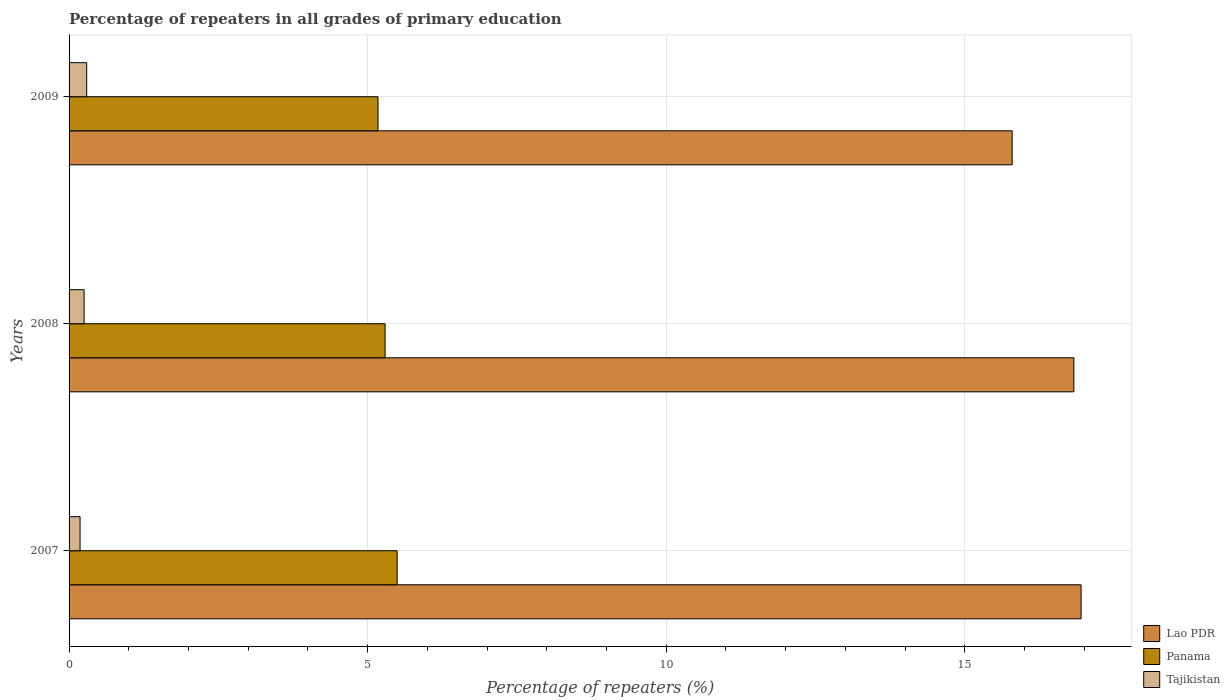How many different coloured bars are there?
Ensure brevity in your answer.  3. How many groups of bars are there?
Your response must be concise. 3. Are the number of bars per tick equal to the number of legend labels?
Provide a short and direct response. Yes. Are the number of bars on each tick of the Y-axis equal?
Provide a succinct answer. Yes. What is the percentage of repeaters in Tajikistan in 2008?
Make the answer very short. 0.25. Across all years, what is the maximum percentage of repeaters in Lao PDR?
Keep it short and to the point. 16.95. Across all years, what is the minimum percentage of repeaters in Lao PDR?
Offer a terse response. 15.79. In which year was the percentage of repeaters in Lao PDR maximum?
Your answer should be very brief. 2007. In which year was the percentage of repeaters in Tajikistan minimum?
Your answer should be very brief. 2007. What is the total percentage of repeaters in Panama in the graph?
Ensure brevity in your answer.  15.96. What is the difference between the percentage of repeaters in Panama in 2007 and that in 2009?
Ensure brevity in your answer.  0.32. What is the difference between the percentage of repeaters in Panama in 2009 and the percentage of repeaters in Lao PDR in 2008?
Your response must be concise. -11.65. What is the average percentage of repeaters in Lao PDR per year?
Make the answer very short. 16.52. In the year 2009, what is the difference between the percentage of repeaters in Lao PDR and percentage of repeaters in Tajikistan?
Keep it short and to the point. 15.5. In how many years, is the percentage of repeaters in Tajikistan greater than 9 %?
Offer a terse response. 0. What is the ratio of the percentage of repeaters in Tajikistan in 2008 to that in 2009?
Provide a succinct answer. 0.85. What is the difference between the highest and the second highest percentage of repeaters in Lao PDR?
Provide a succinct answer. 0.12. What is the difference between the highest and the lowest percentage of repeaters in Panama?
Your answer should be compact. 0.32. Is the sum of the percentage of repeaters in Lao PDR in 2007 and 2008 greater than the maximum percentage of repeaters in Panama across all years?
Offer a terse response. Yes. What does the 2nd bar from the top in 2007 represents?
Your answer should be very brief. Panama. What does the 1st bar from the bottom in 2007 represents?
Offer a very short reply. Lao PDR. Is it the case that in every year, the sum of the percentage of repeaters in Panama and percentage of repeaters in Lao PDR is greater than the percentage of repeaters in Tajikistan?
Offer a terse response. Yes. How many bars are there?
Offer a terse response. 9. Does the graph contain any zero values?
Keep it short and to the point. No. How are the legend labels stacked?
Your response must be concise. Vertical. What is the title of the graph?
Ensure brevity in your answer.  Percentage of repeaters in all grades of primary education. What is the label or title of the X-axis?
Provide a short and direct response. Percentage of repeaters (%). What is the Percentage of repeaters (%) of Lao PDR in 2007?
Provide a succinct answer. 16.95. What is the Percentage of repeaters (%) of Panama in 2007?
Offer a very short reply. 5.49. What is the Percentage of repeaters (%) in Tajikistan in 2007?
Provide a short and direct response. 0.18. What is the Percentage of repeaters (%) of Lao PDR in 2008?
Keep it short and to the point. 16.82. What is the Percentage of repeaters (%) in Panama in 2008?
Offer a terse response. 5.29. What is the Percentage of repeaters (%) in Tajikistan in 2008?
Your response must be concise. 0.25. What is the Percentage of repeaters (%) in Lao PDR in 2009?
Ensure brevity in your answer.  15.79. What is the Percentage of repeaters (%) in Panama in 2009?
Your answer should be compact. 5.17. What is the Percentage of repeaters (%) in Tajikistan in 2009?
Give a very brief answer. 0.3. Across all years, what is the maximum Percentage of repeaters (%) in Lao PDR?
Provide a short and direct response. 16.95. Across all years, what is the maximum Percentage of repeaters (%) in Panama?
Your answer should be very brief. 5.49. Across all years, what is the maximum Percentage of repeaters (%) in Tajikistan?
Ensure brevity in your answer.  0.3. Across all years, what is the minimum Percentage of repeaters (%) of Lao PDR?
Provide a short and direct response. 15.79. Across all years, what is the minimum Percentage of repeaters (%) of Panama?
Offer a terse response. 5.17. Across all years, what is the minimum Percentage of repeaters (%) of Tajikistan?
Your answer should be compact. 0.18. What is the total Percentage of repeaters (%) of Lao PDR in the graph?
Offer a very short reply. 49.56. What is the total Percentage of repeaters (%) in Panama in the graph?
Make the answer very short. 15.96. What is the total Percentage of repeaters (%) in Tajikistan in the graph?
Offer a very short reply. 0.73. What is the difference between the Percentage of repeaters (%) of Lao PDR in 2007 and that in 2008?
Your response must be concise. 0.12. What is the difference between the Percentage of repeaters (%) in Panama in 2007 and that in 2008?
Provide a short and direct response. 0.2. What is the difference between the Percentage of repeaters (%) in Tajikistan in 2007 and that in 2008?
Your response must be concise. -0.07. What is the difference between the Percentage of repeaters (%) in Lao PDR in 2007 and that in 2009?
Make the answer very short. 1.15. What is the difference between the Percentage of repeaters (%) of Panama in 2007 and that in 2009?
Your answer should be very brief. 0.32. What is the difference between the Percentage of repeaters (%) of Tajikistan in 2007 and that in 2009?
Make the answer very short. -0.11. What is the difference between the Percentage of repeaters (%) in Lao PDR in 2008 and that in 2009?
Keep it short and to the point. 1.03. What is the difference between the Percentage of repeaters (%) of Panama in 2008 and that in 2009?
Offer a terse response. 0.12. What is the difference between the Percentage of repeaters (%) of Tajikistan in 2008 and that in 2009?
Provide a short and direct response. -0.04. What is the difference between the Percentage of repeaters (%) in Lao PDR in 2007 and the Percentage of repeaters (%) in Panama in 2008?
Offer a terse response. 11.65. What is the difference between the Percentage of repeaters (%) in Lao PDR in 2007 and the Percentage of repeaters (%) in Tajikistan in 2008?
Your answer should be compact. 16.69. What is the difference between the Percentage of repeaters (%) in Panama in 2007 and the Percentage of repeaters (%) in Tajikistan in 2008?
Your response must be concise. 5.24. What is the difference between the Percentage of repeaters (%) in Lao PDR in 2007 and the Percentage of repeaters (%) in Panama in 2009?
Provide a short and direct response. 11.77. What is the difference between the Percentage of repeaters (%) in Lao PDR in 2007 and the Percentage of repeaters (%) in Tajikistan in 2009?
Your response must be concise. 16.65. What is the difference between the Percentage of repeaters (%) of Panama in 2007 and the Percentage of repeaters (%) of Tajikistan in 2009?
Provide a short and direct response. 5.2. What is the difference between the Percentage of repeaters (%) of Lao PDR in 2008 and the Percentage of repeaters (%) of Panama in 2009?
Keep it short and to the point. 11.65. What is the difference between the Percentage of repeaters (%) of Lao PDR in 2008 and the Percentage of repeaters (%) of Tajikistan in 2009?
Keep it short and to the point. 16.53. What is the difference between the Percentage of repeaters (%) of Panama in 2008 and the Percentage of repeaters (%) of Tajikistan in 2009?
Offer a very short reply. 5. What is the average Percentage of repeaters (%) of Lao PDR per year?
Offer a terse response. 16.52. What is the average Percentage of repeaters (%) in Panama per year?
Give a very brief answer. 5.32. What is the average Percentage of repeaters (%) of Tajikistan per year?
Provide a succinct answer. 0.24. In the year 2007, what is the difference between the Percentage of repeaters (%) in Lao PDR and Percentage of repeaters (%) in Panama?
Your answer should be compact. 11.45. In the year 2007, what is the difference between the Percentage of repeaters (%) of Lao PDR and Percentage of repeaters (%) of Tajikistan?
Your answer should be very brief. 16.76. In the year 2007, what is the difference between the Percentage of repeaters (%) in Panama and Percentage of repeaters (%) in Tajikistan?
Make the answer very short. 5.31. In the year 2008, what is the difference between the Percentage of repeaters (%) in Lao PDR and Percentage of repeaters (%) in Panama?
Give a very brief answer. 11.53. In the year 2008, what is the difference between the Percentage of repeaters (%) of Lao PDR and Percentage of repeaters (%) of Tajikistan?
Keep it short and to the point. 16.57. In the year 2008, what is the difference between the Percentage of repeaters (%) of Panama and Percentage of repeaters (%) of Tajikistan?
Keep it short and to the point. 5.04. In the year 2009, what is the difference between the Percentage of repeaters (%) of Lao PDR and Percentage of repeaters (%) of Panama?
Your answer should be very brief. 10.62. In the year 2009, what is the difference between the Percentage of repeaters (%) in Lao PDR and Percentage of repeaters (%) in Tajikistan?
Ensure brevity in your answer.  15.5. In the year 2009, what is the difference between the Percentage of repeaters (%) in Panama and Percentage of repeaters (%) in Tajikistan?
Provide a succinct answer. 4.88. What is the ratio of the Percentage of repeaters (%) of Lao PDR in 2007 to that in 2008?
Make the answer very short. 1.01. What is the ratio of the Percentage of repeaters (%) in Panama in 2007 to that in 2008?
Provide a succinct answer. 1.04. What is the ratio of the Percentage of repeaters (%) in Tajikistan in 2007 to that in 2008?
Your answer should be very brief. 0.73. What is the ratio of the Percentage of repeaters (%) of Lao PDR in 2007 to that in 2009?
Your answer should be compact. 1.07. What is the ratio of the Percentage of repeaters (%) in Panama in 2007 to that in 2009?
Your answer should be very brief. 1.06. What is the ratio of the Percentage of repeaters (%) of Tajikistan in 2007 to that in 2009?
Make the answer very short. 0.62. What is the ratio of the Percentage of repeaters (%) of Lao PDR in 2008 to that in 2009?
Provide a short and direct response. 1.07. What is the ratio of the Percentage of repeaters (%) of Panama in 2008 to that in 2009?
Keep it short and to the point. 1.02. What is the ratio of the Percentage of repeaters (%) of Tajikistan in 2008 to that in 2009?
Give a very brief answer. 0.85. What is the difference between the highest and the second highest Percentage of repeaters (%) in Lao PDR?
Offer a very short reply. 0.12. What is the difference between the highest and the second highest Percentage of repeaters (%) of Panama?
Your answer should be very brief. 0.2. What is the difference between the highest and the second highest Percentage of repeaters (%) of Tajikistan?
Make the answer very short. 0.04. What is the difference between the highest and the lowest Percentage of repeaters (%) in Lao PDR?
Offer a very short reply. 1.15. What is the difference between the highest and the lowest Percentage of repeaters (%) in Panama?
Keep it short and to the point. 0.32. What is the difference between the highest and the lowest Percentage of repeaters (%) of Tajikistan?
Keep it short and to the point. 0.11. 